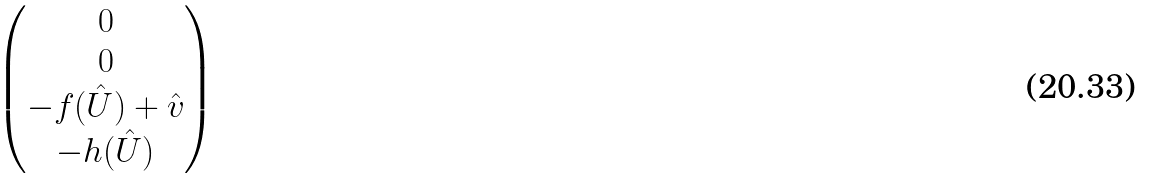Convert formula to latex. <formula><loc_0><loc_0><loc_500><loc_500>\begin{pmatrix} 0 \\ 0 \\ - f ( \hat { U } ) + \hat { v } \\ - h ( \hat { U } ) \\ \end{pmatrix}</formula> 